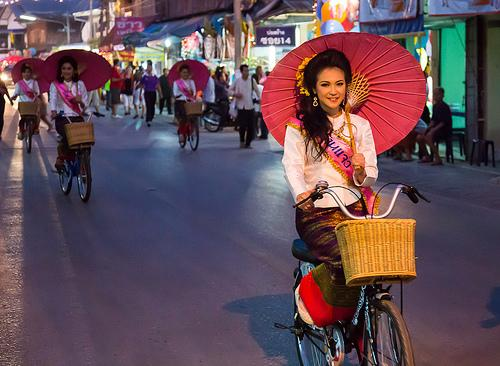Provide a brief overview of the scene depicted in the image. A woman with dark hair and earrings is riding a bicycle with a basket while holding a red umbrella, surrounded by other people, bikes, and buildings in the background. Describe the contents of the main subject's bicycle's front part. The front part of the main subject's bicycle has a brown wicker basket and silver bicycle bell. Describe the scene behind the main subject in the image. People are walking down the street, some on bikes with woven baskets and pink umbrellas, near lit up storefronts and buildings lining the street. State the color and type of the object held by the main subject in the image. The main subject is holding a red paper umbrella. How is the main subject holding onto the bicycle? The main subject is holding the bicycle by its handlebars with one hand while holding an umbrella in the other hand. Give a brief description of the people in the background of the image. In the background, there are people walking, some wearing blue shirts or sitting on benches, and a group of women riding bikes. Mention the type and color of flowers in the girl's hair. The girl has yellow flowers in her hair. Identify the clothing accessory worn by the main subject and its color. The main subject is wearing a pink sash with blue writing. What can you see in the sky in the image? In the image, there is a street lamp that is lit up and appears to be on. Mention the appearance of the ground and any notable details. The ground is gray, made of asphalt, and has a flat pavement with a shadow. 